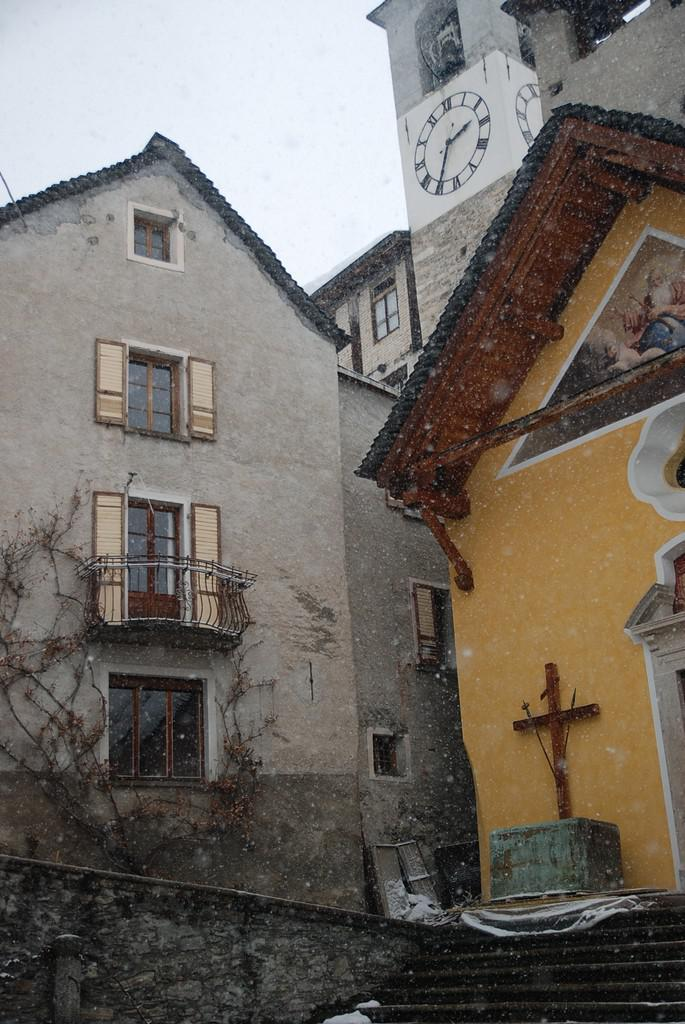What type of structures can be seen in the image? There are many buildings in the image. Can you describe a specific part of a building in the image? The image contains a window of a building. What architectural feature is visible in the image? There are stairs visible in the image. What symbol is present in the image? A cross symbol is present in the image. What time-keeping device is visible in the image? There is a clock in the image. What type of vegetation can be seen in the image? A plant is visible in the image. What outdoor feature is present in the image? There is a balcony in the image. What part of the natural environment is visible in the image? The sky is visible in the image. How does the vest move along the railway in the image? There is no vest or railway present in the image; it features buildings, a window, stairs, a cross symbol, a clock, a plant, a balcony, and the sky. 